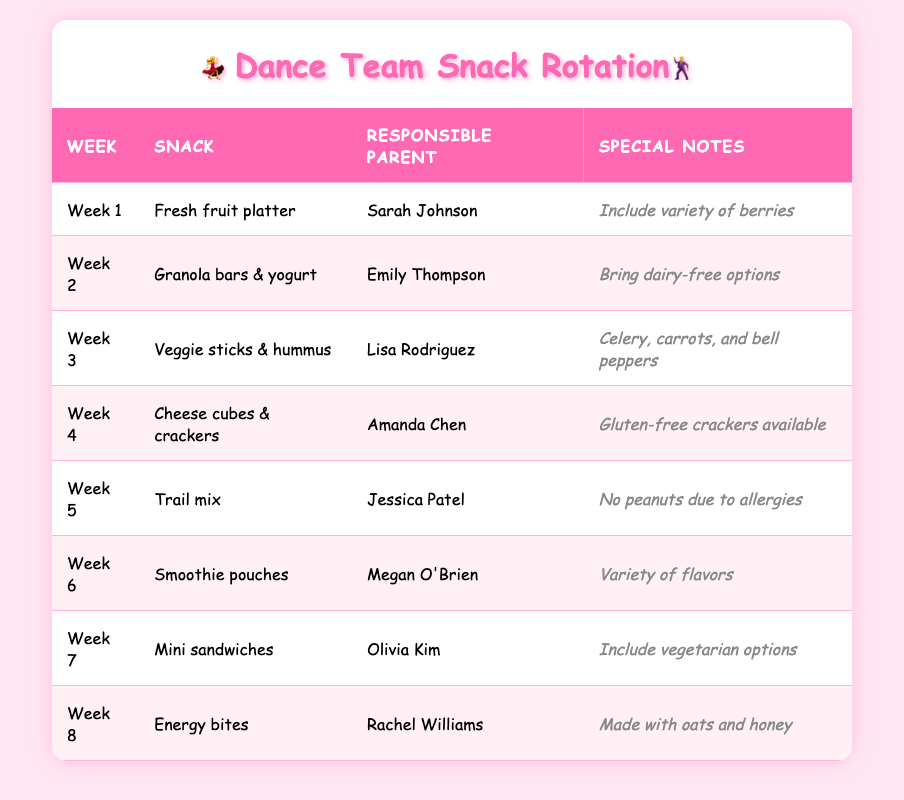What snack is provided in Week 3? Looking at the Week column, Week 3 corresponds to "Veggie sticks & hummus" in the Snack column.
Answer: Veggie sticks & hummus Who is responsible for snacks in Week 5? The table indicates that Jessica Patel is responsible for the snacks in Week 5.
Answer: Jessica Patel Are there any dairy-free options available during the snack rotation? Yes, in Week 2, the special note mentions to "bring dairy-free options" for granola bars & yogurt.
Answer: Yes What type of snack has a special note about vegetarian options? In Week 7, the special note states to "include vegetarian options" for mini sandwiches.
Answer: Mini sandwiches How many different parents are responsible for snacks in the rotation? Counting the names in the Responsible Parent column, there are 8 unique parents listed for the 8 weeks.
Answer: 8 What snack is scheduled for Week 4, and does it offer gluten-free options? Week 4 features cheese cubes & crackers, and the special note confirms that gluten-free crackers are available.
Answer: Cheese cubes & crackers, yes Which week features a snack that includes oats and honey? Looking at the table, Week 8 has energy bites, which are described as "made with oats and honey."
Answer: Week 8 Which snack has a special note regarding peanut allergies? Week 5 features trail mix, and the special note explicitly states "no peanuts due to allergies."
Answer: Trail mix Do any of the snacks include fresh fruit? If so, which week? Yes, the fresh fruit platter is scheduled for Week 1.
Answer: Week 1 